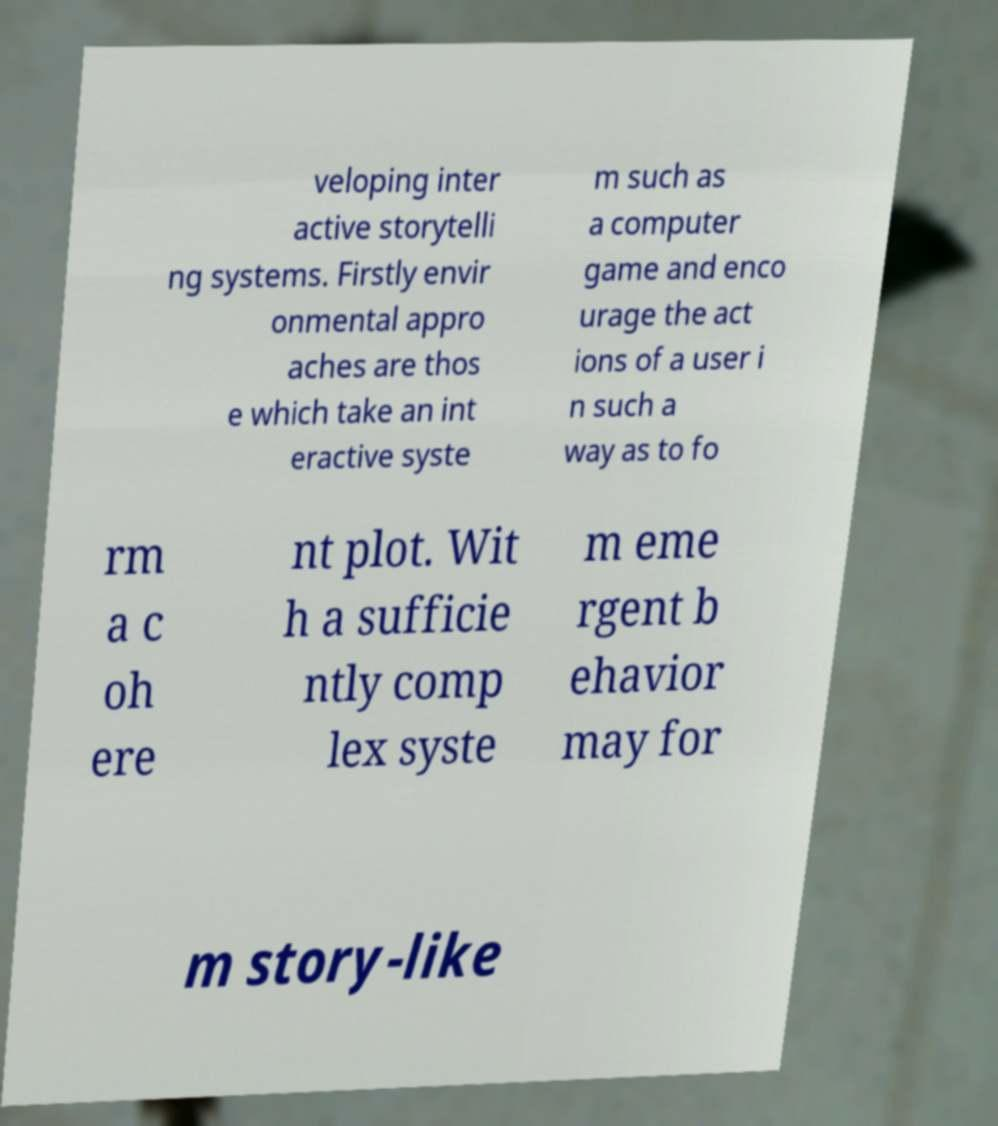Please identify and transcribe the text found in this image. veloping inter active storytelli ng systems. Firstly envir onmental appro aches are thos e which take an int eractive syste m such as a computer game and enco urage the act ions of a user i n such a way as to fo rm a c oh ere nt plot. Wit h a sufficie ntly comp lex syste m eme rgent b ehavior may for m story-like 